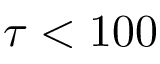Convert formula to latex. <formula><loc_0><loc_0><loc_500><loc_500>\tau < 1 0 0</formula> 